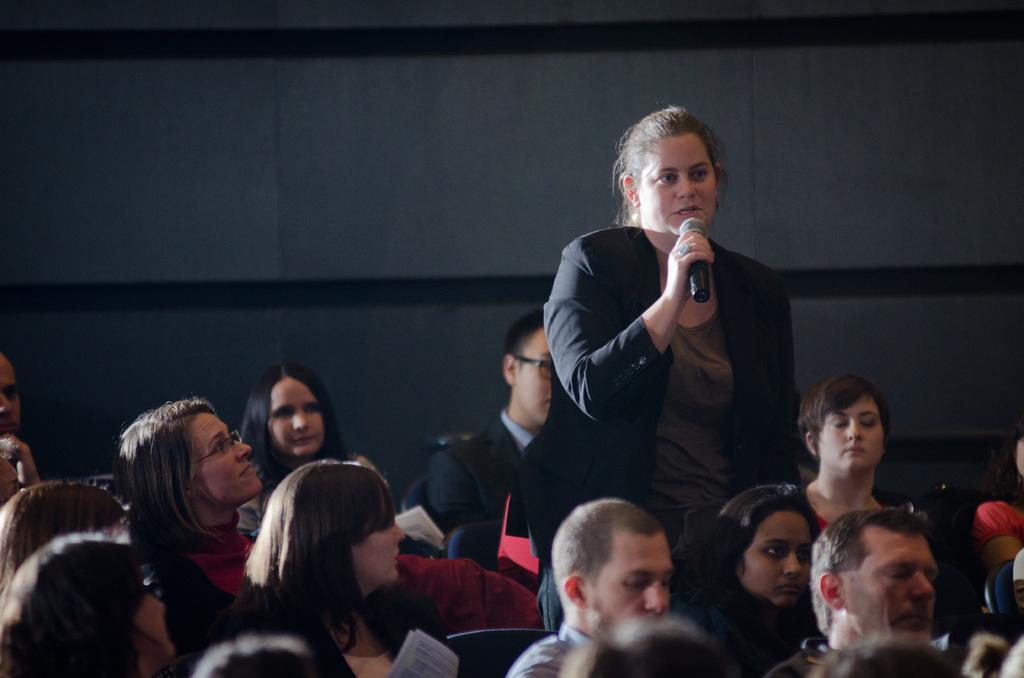Can you describe this image briefly? In this image I can see group of people sitting on the chairs, in front I can see the person standing holding a microphone wearing black dress. Background I can see a wall in gray and black color. 